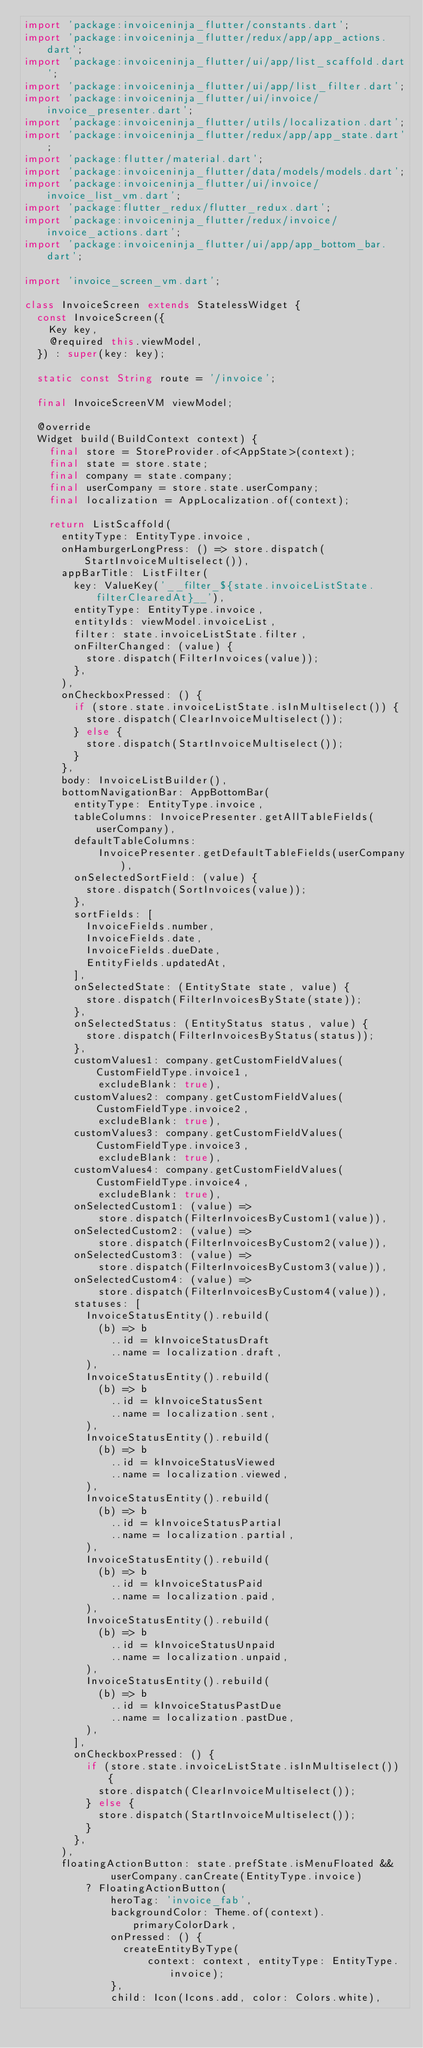<code> <loc_0><loc_0><loc_500><loc_500><_Dart_>import 'package:invoiceninja_flutter/constants.dart';
import 'package:invoiceninja_flutter/redux/app/app_actions.dart';
import 'package:invoiceninja_flutter/ui/app/list_scaffold.dart';
import 'package:invoiceninja_flutter/ui/app/list_filter.dart';
import 'package:invoiceninja_flutter/ui/invoice/invoice_presenter.dart';
import 'package:invoiceninja_flutter/utils/localization.dart';
import 'package:invoiceninja_flutter/redux/app/app_state.dart';
import 'package:flutter/material.dart';
import 'package:invoiceninja_flutter/data/models/models.dart';
import 'package:invoiceninja_flutter/ui/invoice/invoice_list_vm.dart';
import 'package:flutter_redux/flutter_redux.dart';
import 'package:invoiceninja_flutter/redux/invoice/invoice_actions.dart';
import 'package:invoiceninja_flutter/ui/app/app_bottom_bar.dart';

import 'invoice_screen_vm.dart';

class InvoiceScreen extends StatelessWidget {
  const InvoiceScreen({
    Key key,
    @required this.viewModel,
  }) : super(key: key);

  static const String route = '/invoice';

  final InvoiceScreenVM viewModel;

  @override
  Widget build(BuildContext context) {
    final store = StoreProvider.of<AppState>(context);
    final state = store.state;
    final company = state.company;
    final userCompany = store.state.userCompany;
    final localization = AppLocalization.of(context);

    return ListScaffold(
      entityType: EntityType.invoice,
      onHamburgerLongPress: () => store.dispatch(StartInvoiceMultiselect()),
      appBarTitle: ListFilter(
        key: ValueKey('__filter_${state.invoiceListState.filterClearedAt}__'),
        entityType: EntityType.invoice,
        entityIds: viewModel.invoiceList,
        filter: state.invoiceListState.filter,
        onFilterChanged: (value) {
          store.dispatch(FilterInvoices(value));
        },
      ),
      onCheckboxPressed: () {
        if (store.state.invoiceListState.isInMultiselect()) {
          store.dispatch(ClearInvoiceMultiselect());
        } else {
          store.dispatch(StartInvoiceMultiselect());
        }
      },
      body: InvoiceListBuilder(),
      bottomNavigationBar: AppBottomBar(
        entityType: EntityType.invoice,
        tableColumns: InvoicePresenter.getAllTableFields(userCompany),
        defaultTableColumns:
            InvoicePresenter.getDefaultTableFields(userCompany),
        onSelectedSortField: (value) {
          store.dispatch(SortInvoices(value));
        },
        sortFields: [
          InvoiceFields.number,
          InvoiceFields.date,
          InvoiceFields.dueDate,
          EntityFields.updatedAt,
        ],
        onSelectedState: (EntityState state, value) {
          store.dispatch(FilterInvoicesByState(state));
        },
        onSelectedStatus: (EntityStatus status, value) {
          store.dispatch(FilterInvoicesByStatus(status));
        },
        customValues1: company.getCustomFieldValues(CustomFieldType.invoice1,
            excludeBlank: true),
        customValues2: company.getCustomFieldValues(CustomFieldType.invoice2,
            excludeBlank: true),
        customValues3: company.getCustomFieldValues(CustomFieldType.invoice3,
            excludeBlank: true),
        customValues4: company.getCustomFieldValues(CustomFieldType.invoice4,
            excludeBlank: true),
        onSelectedCustom1: (value) =>
            store.dispatch(FilterInvoicesByCustom1(value)),
        onSelectedCustom2: (value) =>
            store.dispatch(FilterInvoicesByCustom2(value)),
        onSelectedCustom3: (value) =>
            store.dispatch(FilterInvoicesByCustom3(value)),
        onSelectedCustom4: (value) =>
            store.dispatch(FilterInvoicesByCustom4(value)),
        statuses: [
          InvoiceStatusEntity().rebuild(
            (b) => b
              ..id = kInvoiceStatusDraft
              ..name = localization.draft,
          ),
          InvoiceStatusEntity().rebuild(
            (b) => b
              ..id = kInvoiceStatusSent
              ..name = localization.sent,
          ),
          InvoiceStatusEntity().rebuild(
            (b) => b
              ..id = kInvoiceStatusViewed
              ..name = localization.viewed,
          ),
          InvoiceStatusEntity().rebuild(
            (b) => b
              ..id = kInvoiceStatusPartial
              ..name = localization.partial,
          ),
          InvoiceStatusEntity().rebuild(
            (b) => b
              ..id = kInvoiceStatusPaid
              ..name = localization.paid,
          ),
          InvoiceStatusEntity().rebuild(
            (b) => b
              ..id = kInvoiceStatusUnpaid
              ..name = localization.unpaid,
          ),
          InvoiceStatusEntity().rebuild(
            (b) => b
              ..id = kInvoiceStatusPastDue
              ..name = localization.pastDue,
          ),
        ],
        onCheckboxPressed: () {
          if (store.state.invoiceListState.isInMultiselect()) {
            store.dispatch(ClearInvoiceMultiselect());
          } else {
            store.dispatch(StartInvoiceMultiselect());
          }
        },
      ),
      floatingActionButton: state.prefState.isMenuFloated &&
              userCompany.canCreate(EntityType.invoice)
          ? FloatingActionButton(
              heroTag: 'invoice_fab',
              backgroundColor: Theme.of(context).primaryColorDark,
              onPressed: () {
                createEntityByType(
                    context: context, entityType: EntityType.invoice);
              },
              child: Icon(Icons.add, color: Colors.white),</code> 